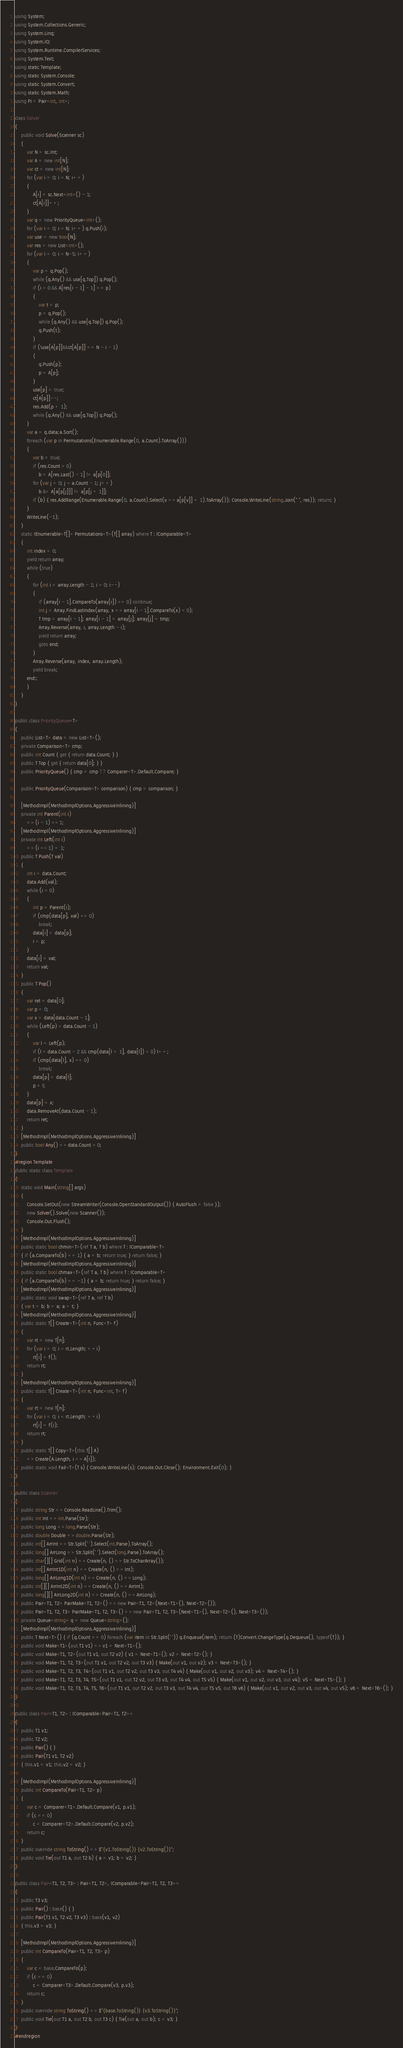<code> <loc_0><loc_0><loc_500><loc_500><_C#_>using System;
using System.Collections.Generic;
using System.Linq;
using System.IO;
using System.Runtime.CompilerServices;
using System.Text;
using static Template;
using static System.Console;
using static System.Convert;
using static System.Math;
using Pi = Pair<int, int>;

class Solver
{
    public void Solve(Scanner sc)
    {
        var N = sc.Int;
        var A = new int[N];
        var ct = new int[N];
        for (var i = 0; i < N; i++)
        {
            A[i] = sc.Next<int>() - 1;
            ct[A[i]]++;
        }
        var q = new PriorityQueue<int>();
        for (var i = 0; i < N; i++) q.Push(i);
        var use = new bool[N];
        var res = new List<int>();
        for (var i = 0; i < N-5; i++)
        {
            var p = q.Pop();
            while (q.Any() && use[q.Top]) q.Pop(); 
            if (i > 0 && A[res[i - 1] - 1] == p)
            {
                var t = p;
                p = q.Pop();
                while (q.Any() && use[q.Top]) q.Pop();
                q.Push(t);
            }
            if (!use[A[p]]&&ct[A[p]] == N - i - 1)
            {
                q.Push(p);
                p = A[p];
            }
            use[p] = true;
            ct[A[p]]--;
            res.Add(p + 1);
            while (q.Any() && use[q.Top]) q.Pop();
        }
        var a = q.data;a.Sort();
        foreach (var p in Permutations(Enumerable.Range(0, a.Count).ToArray()))
        {
            var b = true;
            if (res.Count > 0)
                b = A[res.Last() - 1] != a[p[0]];
            for (var j = 0; j < a.Count - 1; j++)
                b &= A[a[p[j]]] != a[p[j + 1]];
            if (b) { res.AddRange(Enumerable.Range(0, a.Count).Select(v => a[p[v]] + 1).ToArray()); Console.WriteLine(string.Join(" ", res)); return; }
        }
        WriteLine(-1);
    }
    static IEnumerable<T[]> Permutations<T>(T[] array) where T : IComparable<T>
    {
        int index = 0;
        yield return array;
        while (true)
        {
            for (int i = array.Length - 1; i > 0; i--)
            {
                if (array[i - 1].CompareTo(array[i]) >= 0) continue;
                int j = Array.FindLastIndex(array, x => array[i - 1].CompareTo(x) < 0);
                T tmp = array[i - 1]; array[i - 1] = array[j]; array[j] = tmp;
                Array.Reverse(array, i, array.Length - i);
                yield return array;
                goto end;
            }
            Array.Reverse(array, index, array.Length);
            yield break;
        end:;
        }
    }
}

public class PriorityQueue<T>
{
    public List<T> data = new List<T>();
    private Comparison<T> cmp;
    public int Count { get { return data.Count; } }
    public T Top { get { return data[0]; } }
    public PriorityQueue() { cmp = cmp ?? Comparer<T>.Default.Compare; }

    public PriorityQueue(Comparison<T> comparison) { cmp = comparison; }

    [MethodImpl(MethodImplOptions.AggressiveInlining)]
    private int Parent(int i)
        => (i - 1) >> 1;
    [MethodImpl(MethodImplOptions.AggressiveInlining)]
    private int Left(int i)
        => (i << 1) + 1;
    public T Push(T val)
    {
        int i = data.Count;
        data.Add(val);
        while (i > 0)
        {
            int p = Parent(i);
            if (cmp(data[p], val) <= 0)
                break;
            data[i] = data[p];
            i = p;
        }
        data[i] = val;
        return val;
    }
    public T Pop()
    {
        var ret = data[0];
        var p = 0;
        var x = data[data.Count - 1];
        while (Left(p) < data.Count - 1)
        {
            var l = Left(p);
            if (l < data.Count - 2 && cmp(data[l + 1], data[l]) < 0) l++;
            if (cmp(data[l], x) >= 0)
                break;
            data[p] = data[l];
            p = l;
        }
        data[p] = x;
        data.RemoveAt(data.Count - 1);
        return ret;
    }
    [MethodImpl(MethodImplOptions.AggressiveInlining)]
    public bool Any() => data.Count > 0;
}
#region Template
public static class Template
{
    static void Main(string[] args)
    {
        Console.SetOut(new StreamWriter(Console.OpenStandardOutput()) { AutoFlush = false });
        new Solver().Solve(new Scanner());
        Console.Out.Flush();
    }
    [MethodImpl(MethodImplOptions.AggressiveInlining)]
    public static bool chmin<T>(ref T a, T b) where T : IComparable<T>
    { if (a.CompareTo(b) == 1) { a = b; return true; } return false; }
    [MethodImpl(MethodImplOptions.AggressiveInlining)]
    public static bool chmax<T>(ref T a, T b) where T : IComparable<T>
    { if (a.CompareTo(b) == -1) { a = b; return true; } return false; }
    [MethodImpl(MethodImplOptions.AggressiveInlining)]
    public static void swap<T>(ref T a, ref T b)
    { var t = b; b = a; a = t; }
    [MethodImpl(MethodImplOptions.AggressiveInlining)]
    public static T[] Create<T>(int n, Func<T> f)
    {
        var rt = new T[n];
        for (var i = 0; i < rt.Length; ++i)
            rt[i] = f();
        return rt;
    }
    [MethodImpl(MethodImplOptions.AggressiveInlining)]
    public static T[] Create<T>(int n, Func<int, T> f)
    {
        var rt = new T[n];
        for (var i = 0; i < rt.Length; ++i)
            rt[i] = f(i);
        return rt;
    }
    public static T[] Copy<T>(this T[] A)
        => Create(A.Length, i => A[i]);
    public static void Fail<T>(T s) { Console.WriteLine(s); Console.Out.Close(); Environment.Exit(0); }
}

public class Scanner
{
    public string Str => Console.ReadLine().Trim();
    public int Int => int.Parse(Str);
    public long Long => long.Parse(Str);
    public double Double => double.Parse(Str);
    public int[] ArrInt => Str.Split(' ').Select(int.Parse).ToArray();
    public long[] ArrLong => Str.Split(' ').Select(long.Parse).ToArray();
    public char[][] Grid(int n) => Create(n, () => Str.ToCharArray());
    public int[] ArrInt1D(int n) => Create(n, () => Int);
    public long[] ArrLong1D(int n) => Create(n, () => Long);
    public int[][] ArrInt2D(int n) => Create(n, () => ArrInt);
    public long[][] ArrLong2D(int n) => Create(n, () => ArrLong);
    public Pair<T1, T2> PairMake<T1, T2>() => new Pair<T1, T2>(Next<T1>(), Next<T2>());
    public Pair<T1, T2, T3> PairMake<T1, T2, T3>() => new Pair<T1, T2, T3>(Next<T1>(), Next<T2>(), Next<T3>());
    private Queue<string> q = new Queue<string>();
    [MethodImpl(MethodImplOptions.AggressiveInlining)]
    public T Next<T>() { if (q.Count == 0) foreach (var item in Str.Split(' ')) q.Enqueue(item); return (T)Convert.ChangeType(q.Dequeue(), typeof(T)); }
    public void Make<T1>(out T1 v1) => v1 = Next<T1>();
    public void Make<T1, T2>(out T1 v1, out T2 v2) { v1 = Next<T1>(); v2 = Next<T2>(); }
    public void Make<T1, T2, T3>(out T1 v1, out T2 v2, out T3 v3) { Make(out v1, out v2); v3 = Next<T3>(); }
    public void Make<T1, T2, T3, T4>(out T1 v1, out T2 v2, out T3 v3, out T4 v4) { Make(out v1, out v2, out v3); v4 = Next<T4>(); }
    public void Make<T1, T2, T3, T4, T5>(out T1 v1, out T2 v2, out T3 v3, out T4 v4, out T5 v5) { Make(out v1, out v2, out v3, out v4); v5 = Next<T5>(); }
    public void Make<T1, T2, T3, T4, T5, T6>(out T1 v1, out T2 v2, out T3 v3, out T4 v4, out T5 v5, out T6 v6) { Make(out v1, out v2, out v3, out v4, out v5); v6 = Next<T6>(); }
}

public class Pair<T1, T2> : IComparable<Pair<T1, T2>>
{
    public T1 v1;
    public T2 v2;
    public Pair() { }
    public Pair(T1 v1, T2 v2)
    { this.v1 = v1; this.v2 = v2; }

    [MethodImpl(MethodImplOptions.AggressiveInlining)]
    public int CompareTo(Pair<T1, T2> p)
    {
        var c = Comparer<T1>.Default.Compare(v1, p.v1);
        if (c == 0)
            c = Comparer<T2>.Default.Compare(v2, p.v2);
        return c;
    }
    public override string ToString() => $"{v1.ToString()} {v2.ToString()}";
    public void Tie(out T1 a, out T2 b) { a = v1; b = v2; }
}

public class Pair<T1, T2, T3> : Pair<T1, T2>, IComparable<Pair<T1, T2, T3>>
{
    public T3 v3;
    public Pair() : base() { }
    public Pair(T1 v1, T2 v2, T3 v3) : base(v1, v2)
    { this.v3 = v3; }

    [MethodImpl(MethodImplOptions.AggressiveInlining)]
    public int CompareTo(Pair<T1, T2, T3> p)
    {
        var c = base.CompareTo(p);
        if (c == 0)
            c = Comparer<T3>.Default.Compare(v3, p.v3);
        return c;
    }
    public override string ToString() => $"{base.ToString()} {v3.ToString()}";
    public void Tie(out T1 a, out T2 b, out T3 c) { Tie(out a, out b); c = v3; }
}
#endregion
</code> 